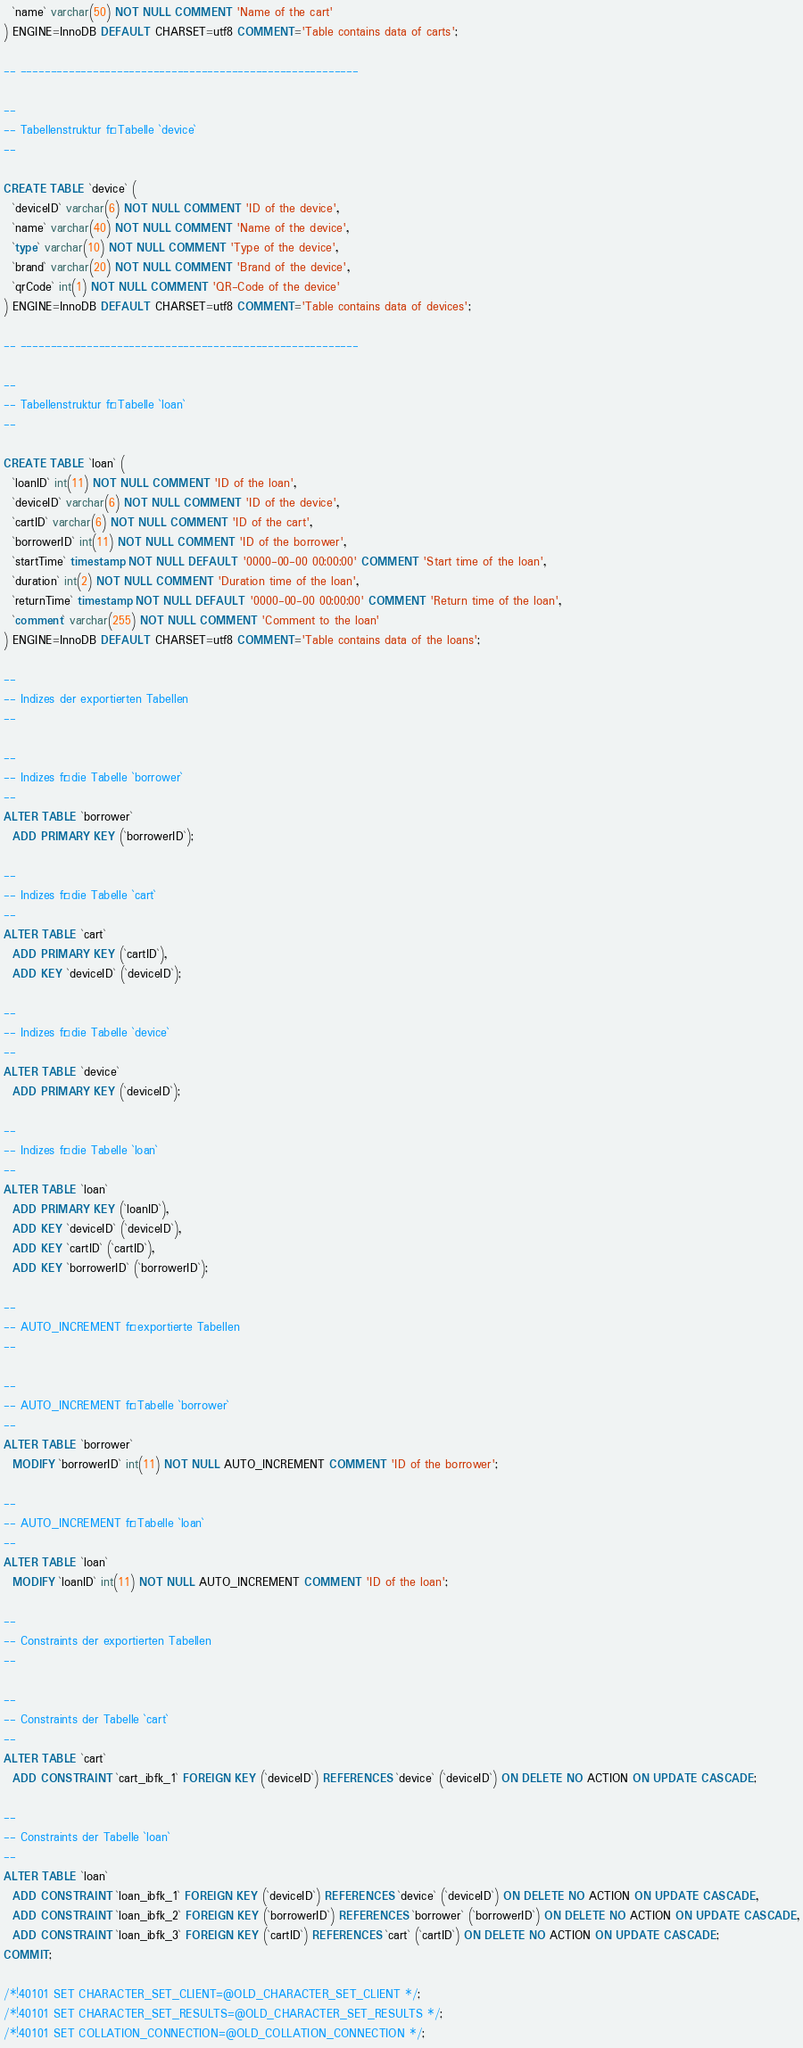Convert code to text. <code><loc_0><loc_0><loc_500><loc_500><_SQL_>  `name` varchar(50) NOT NULL COMMENT 'Name of the cart'
) ENGINE=InnoDB DEFAULT CHARSET=utf8 COMMENT='Table contains data of carts';

-- --------------------------------------------------------

--
-- Tabellenstruktur für Tabelle `device`
--

CREATE TABLE `device` (
  `deviceID` varchar(6) NOT NULL COMMENT 'ID of the device',
  `name` varchar(40) NOT NULL COMMENT 'Name of the device',
  `type` varchar(10) NOT NULL COMMENT 'Type of the device',
  `brand` varchar(20) NOT NULL COMMENT 'Brand of the device',
  `qrCode` int(1) NOT NULL COMMENT 'QR-Code of the device'
) ENGINE=InnoDB DEFAULT CHARSET=utf8 COMMENT='Table contains data of devices';

-- --------------------------------------------------------

--
-- Tabellenstruktur für Tabelle `loan`
--

CREATE TABLE `loan` (
  `loanID` int(11) NOT NULL COMMENT 'ID of the loan',
  `deviceID` varchar(6) NOT NULL COMMENT 'ID of the device',
  `cartID` varchar(6) NOT NULL COMMENT 'ID of the cart',
  `borrowerID` int(11) NOT NULL COMMENT 'ID of the borrower',
  `startTime` timestamp NOT NULL DEFAULT '0000-00-00 00:00:00' COMMENT 'Start time of the loan',
  `duration` int(2) NOT NULL COMMENT 'Duration time of the loan',
  `returnTime` timestamp NOT NULL DEFAULT '0000-00-00 00:00:00' COMMENT 'Return time of the loan',
  `comment` varchar(255) NOT NULL COMMENT 'Comment to the loan'
) ENGINE=InnoDB DEFAULT CHARSET=utf8 COMMENT='Table contains data of the loans';

--
-- Indizes der exportierten Tabellen
--

--
-- Indizes für die Tabelle `borrower`
--
ALTER TABLE `borrower`
  ADD PRIMARY KEY (`borrowerID`);

--
-- Indizes für die Tabelle `cart`
--
ALTER TABLE `cart`
  ADD PRIMARY KEY (`cartID`),
  ADD KEY `deviceID` (`deviceID`);

--
-- Indizes für die Tabelle `device`
--
ALTER TABLE `device`
  ADD PRIMARY KEY (`deviceID`);

--
-- Indizes für die Tabelle `loan`
--
ALTER TABLE `loan`
  ADD PRIMARY KEY (`loanID`),
  ADD KEY `deviceID` (`deviceID`),
  ADD KEY `cartID` (`cartID`),
  ADD KEY `borrowerID` (`borrowerID`);

--
-- AUTO_INCREMENT für exportierte Tabellen
--

--
-- AUTO_INCREMENT für Tabelle `borrower`
--
ALTER TABLE `borrower`
  MODIFY `borrowerID` int(11) NOT NULL AUTO_INCREMENT COMMENT 'ID of the borrower';

--
-- AUTO_INCREMENT für Tabelle `loan`
--
ALTER TABLE `loan`
  MODIFY `loanID` int(11) NOT NULL AUTO_INCREMENT COMMENT 'ID of the loan';

--
-- Constraints der exportierten Tabellen
--

--
-- Constraints der Tabelle `cart`
--
ALTER TABLE `cart`
  ADD CONSTRAINT `cart_ibfk_1` FOREIGN KEY (`deviceID`) REFERENCES `device` (`deviceID`) ON DELETE NO ACTION ON UPDATE CASCADE;

--
-- Constraints der Tabelle `loan`
--
ALTER TABLE `loan`
  ADD CONSTRAINT `loan_ibfk_1` FOREIGN KEY (`deviceID`) REFERENCES `device` (`deviceID`) ON DELETE NO ACTION ON UPDATE CASCADE,
  ADD CONSTRAINT `loan_ibfk_2` FOREIGN KEY (`borrowerID`) REFERENCES `borrower` (`borrowerID`) ON DELETE NO ACTION ON UPDATE CASCADE,
  ADD CONSTRAINT `loan_ibfk_3` FOREIGN KEY (`cartID`) REFERENCES `cart` (`cartID`) ON DELETE NO ACTION ON UPDATE CASCADE;
COMMIT;

/*!40101 SET CHARACTER_SET_CLIENT=@OLD_CHARACTER_SET_CLIENT */;
/*!40101 SET CHARACTER_SET_RESULTS=@OLD_CHARACTER_SET_RESULTS */;
/*!40101 SET COLLATION_CONNECTION=@OLD_COLLATION_CONNECTION */;
</code> 